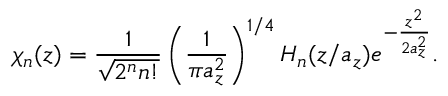Convert formula to latex. <formula><loc_0><loc_0><loc_500><loc_500>\chi _ { n } ( z ) = \frac { 1 } { \sqrt { 2 ^ { n } n ! } } \left ( \frac { 1 } { \pi a _ { z } ^ { 2 } } \right ) ^ { 1 / 4 } H _ { n } ( z / a _ { z } ) e ^ { - \frac { z ^ { 2 } } { 2 a _ { z } ^ { 2 } } } .</formula> 